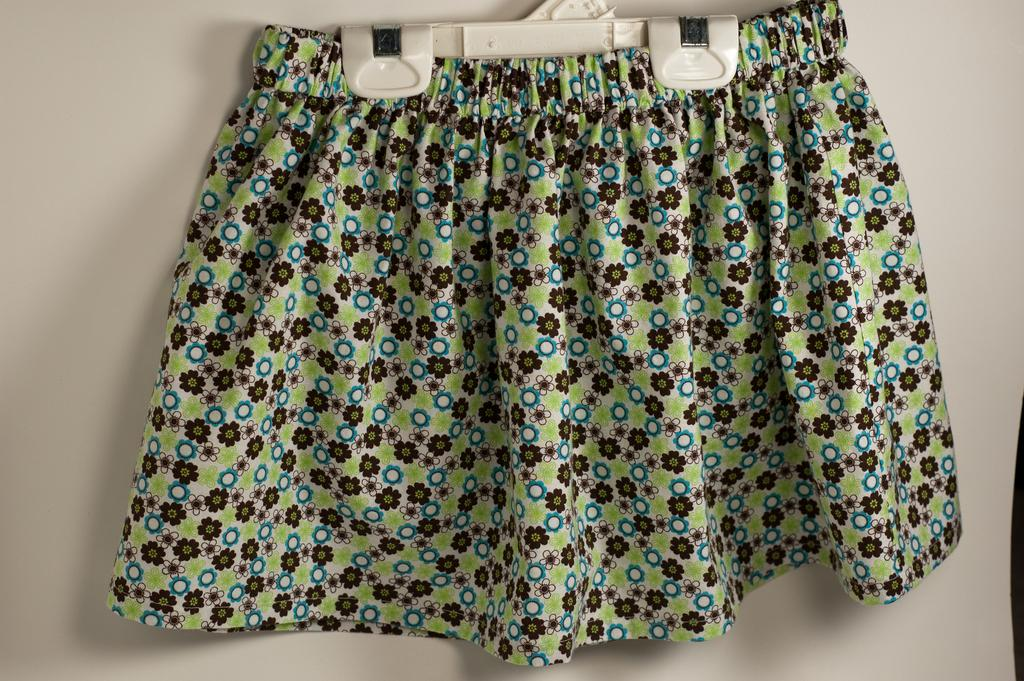What type of clothing is featured in the picture? There is a floral green color mini skirt in the picture. What is the color of the background in the picture? There is a white background in the picture. How many teeth can be seen in the picture? There are no teeth visible in the picture, as it features a floral green color mini skirt on a white background. 